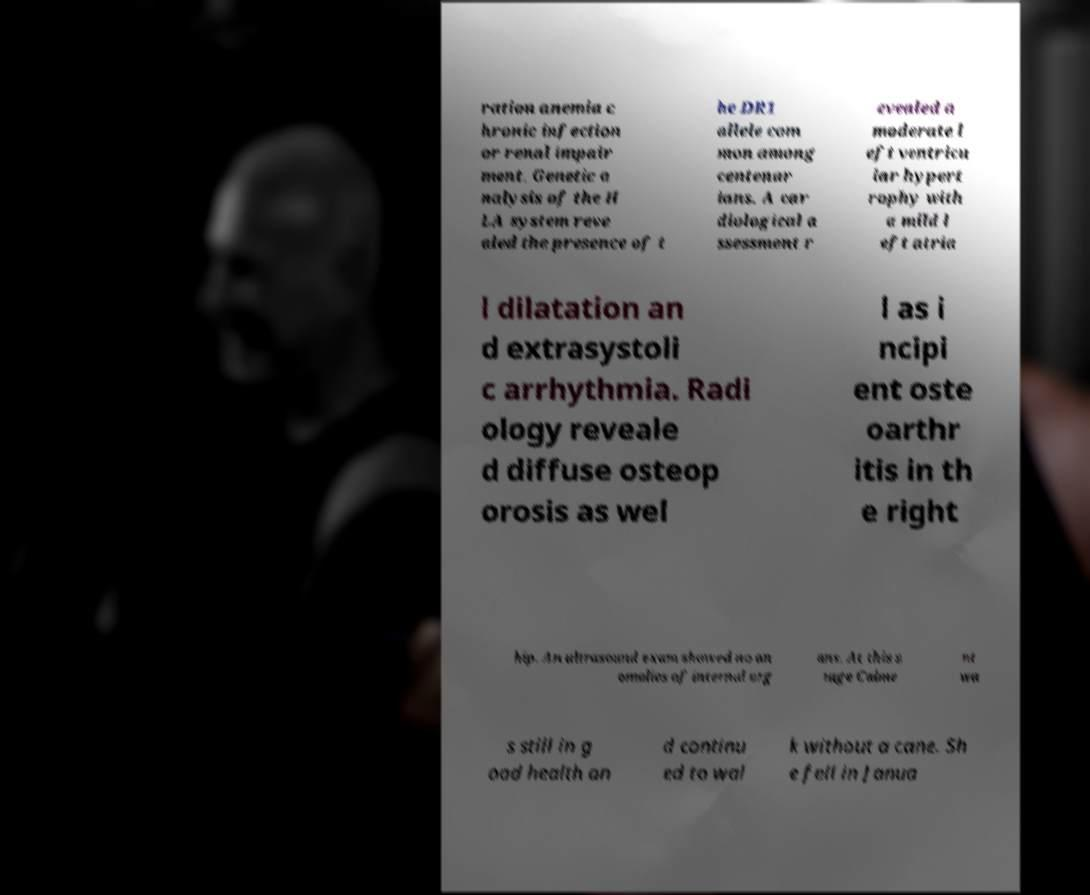I need the written content from this picture converted into text. Can you do that? ration anemia c hronic infection or renal impair ment. Genetic a nalysis of the H LA system reve aled the presence of t he DR1 allele com mon among centenar ians. A car diological a ssessment r evealed a moderate l eft ventricu lar hypert rophy with a mild l eft atria l dilatation an d extrasystoli c arrhythmia. Radi ology reveale d diffuse osteop orosis as wel l as i ncipi ent oste oarthr itis in th e right hip. An ultrasound exam showed no an omalies of internal org ans. At this s tage Calme nt wa s still in g ood health an d continu ed to wal k without a cane. Sh e fell in Janua 